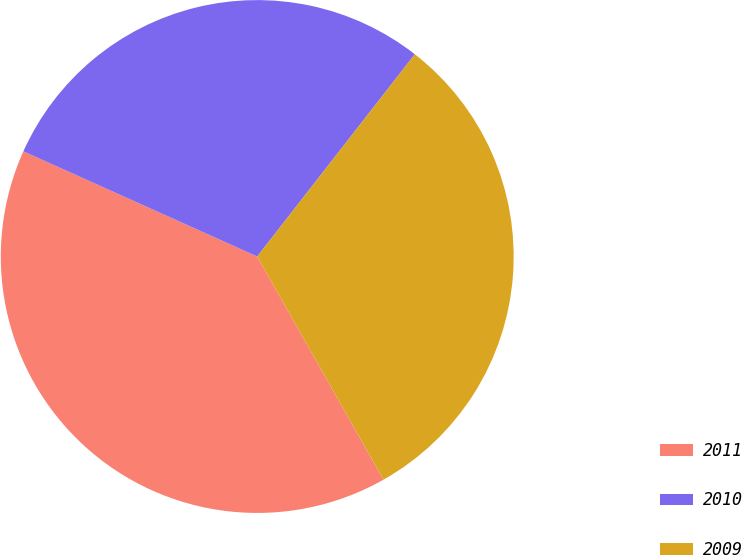Convert chart. <chart><loc_0><loc_0><loc_500><loc_500><pie_chart><fcel>2011<fcel>2010<fcel>2009<nl><fcel>39.92%<fcel>28.81%<fcel>31.27%<nl></chart> 